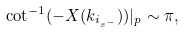Convert formula to latex. <formula><loc_0><loc_0><loc_500><loc_500>\cot ^ { - 1 } ( - X ( k _ { i _ { s ^ { - } } } ) ) | _ { p } \sim \pi ,</formula> 